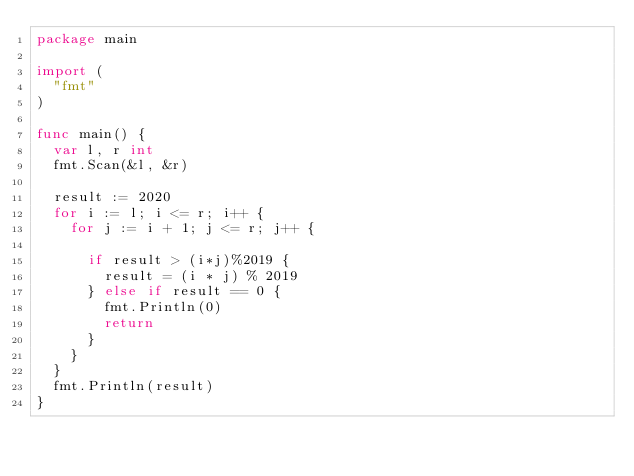<code> <loc_0><loc_0><loc_500><loc_500><_Go_>package main

import (
	"fmt"
)

func main() {
	var l, r int
	fmt.Scan(&l, &r)

	result := 2020
	for i := l; i <= r; i++ {
		for j := i + 1; j <= r; j++ {

			if result > (i*j)%2019 {
				result = (i * j) % 2019
			} else if result == 0 {
				fmt.Println(0)
				return
			}
		}
	}
	fmt.Println(result)
}
</code> 